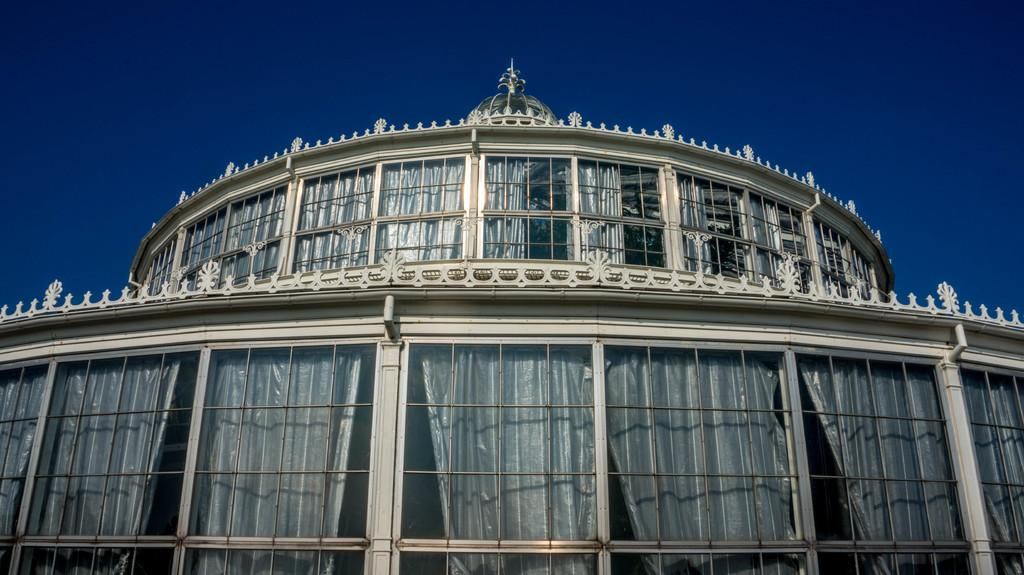What type of structure is present in the image? There is a building in the image. What feature of the building is mentioned in the facts? The building has multiple windows. Are there any window treatments visible in the image? Yes, there are curtains associated with the windows. What can be seen in the background of the image? The sky is visible in the background of the image. What type of coil can be seen in the image? There is no coil present in the image. What is the texture of the building's exterior in the image? The facts provided do not mention the texture of the building's exterior, so it cannot be determined from the image. 